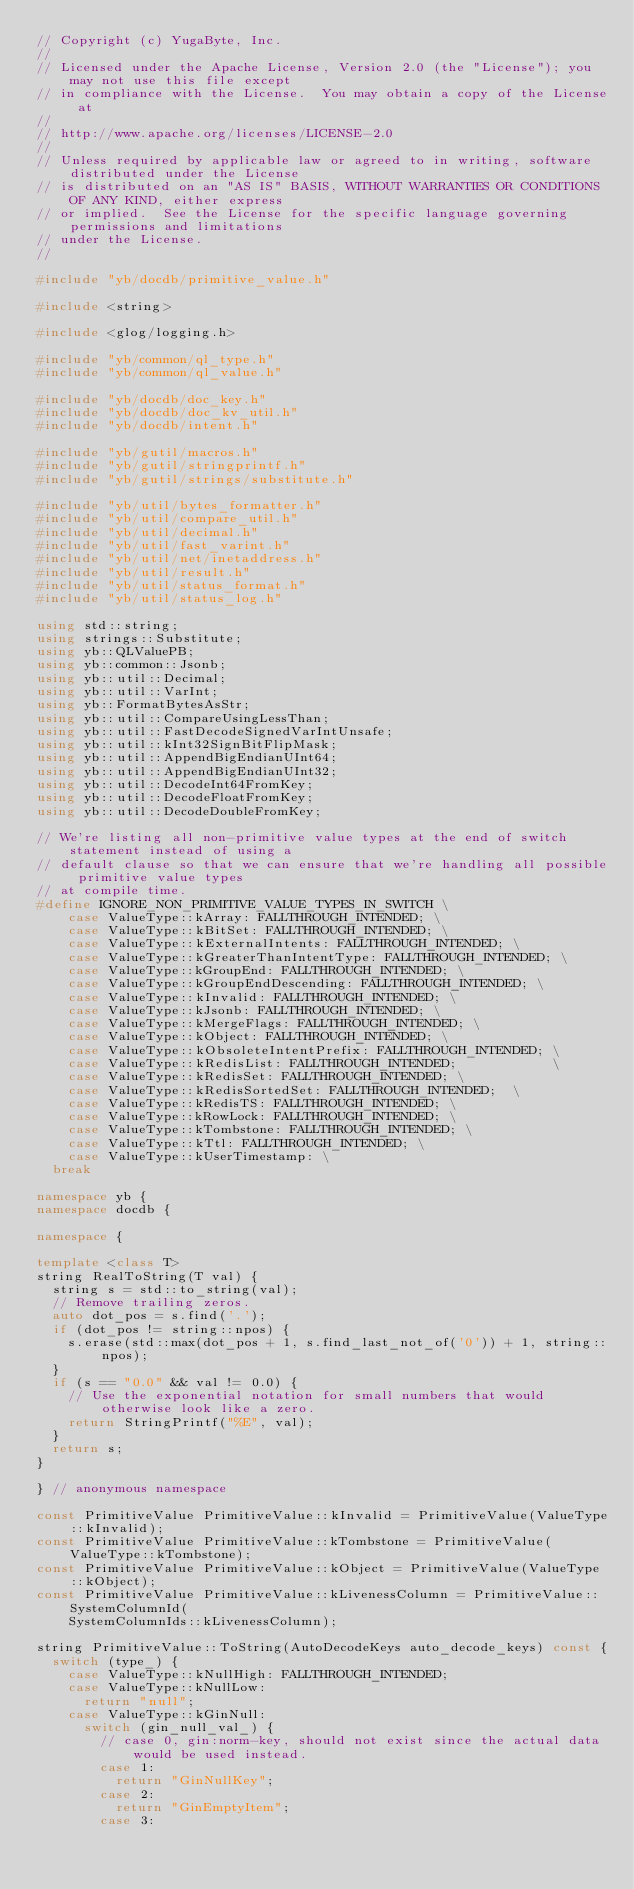Convert code to text. <code><loc_0><loc_0><loc_500><loc_500><_C++_>// Copyright (c) YugaByte, Inc.
//
// Licensed under the Apache License, Version 2.0 (the "License"); you may not use this file except
// in compliance with the License.  You may obtain a copy of the License at
//
// http://www.apache.org/licenses/LICENSE-2.0
//
// Unless required by applicable law or agreed to in writing, software distributed under the License
// is distributed on an "AS IS" BASIS, WITHOUT WARRANTIES OR CONDITIONS OF ANY KIND, either express
// or implied.  See the License for the specific language governing permissions and limitations
// under the License.
//

#include "yb/docdb/primitive_value.h"

#include <string>

#include <glog/logging.h>

#include "yb/common/ql_type.h"
#include "yb/common/ql_value.h"

#include "yb/docdb/doc_key.h"
#include "yb/docdb/doc_kv_util.h"
#include "yb/docdb/intent.h"

#include "yb/gutil/macros.h"
#include "yb/gutil/stringprintf.h"
#include "yb/gutil/strings/substitute.h"

#include "yb/util/bytes_formatter.h"
#include "yb/util/compare_util.h"
#include "yb/util/decimal.h"
#include "yb/util/fast_varint.h"
#include "yb/util/net/inetaddress.h"
#include "yb/util/result.h"
#include "yb/util/status_format.h"
#include "yb/util/status_log.h"

using std::string;
using strings::Substitute;
using yb::QLValuePB;
using yb::common::Jsonb;
using yb::util::Decimal;
using yb::util::VarInt;
using yb::FormatBytesAsStr;
using yb::util::CompareUsingLessThan;
using yb::util::FastDecodeSignedVarIntUnsafe;
using yb::util::kInt32SignBitFlipMask;
using yb::util::AppendBigEndianUInt64;
using yb::util::AppendBigEndianUInt32;
using yb::util::DecodeInt64FromKey;
using yb::util::DecodeFloatFromKey;
using yb::util::DecodeDoubleFromKey;

// We're listing all non-primitive value types at the end of switch statement instead of using a
// default clause so that we can ensure that we're handling all possible primitive value types
// at compile time.
#define IGNORE_NON_PRIMITIVE_VALUE_TYPES_IN_SWITCH \
    case ValueType::kArray: FALLTHROUGH_INTENDED; \
    case ValueType::kBitSet: FALLTHROUGH_INTENDED; \
    case ValueType::kExternalIntents: FALLTHROUGH_INTENDED; \
    case ValueType::kGreaterThanIntentType: FALLTHROUGH_INTENDED; \
    case ValueType::kGroupEnd: FALLTHROUGH_INTENDED; \
    case ValueType::kGroupEndDescending: FALLTHROUGH_INTENDED; \
    case ValueType::kInvalid: FALLTHROUGH_INTENDED; \
    case ValueType::kJsonb: FALLTHROUGH_INTENDED; \
    case ValueType::kMergeFlags: FALLTHROUGH_INTENDED; \
    case ValueType::kObject: FALLTHROUGH_INTENDED; \
    case ValueType::kObsoleteIntentPrefix: FALLTHROUGH_INTENDED; \
    case ValueType::kRedisList: FALLTHROUGH_INTENDED;            \
    case ValueType::kRedisSet: FALLTHROUGH_INTENDED; \
    case ValueType::kRedisSortedSet: FALLTHROUGH_INTENDED;  \
    case ValueType::kRedisTS: FALLTHROUGH_INTENDED; \
    case ValueType::kRowLock: FALLTHROUGH_INTENDED; \
    case ValueType::kTombstone: FALLTHROUGH_INTENDED; \
    case ValueType::kTtl: FALLTHROUGH_INTENDED; \
    case ValueType::kUserTimestamp: \
  break

namespace yb {
namespace docdb {

namespace {

template <class T>
string RealToString(T val) {
  string s = std::to_string(val);
  // Remove trailing zeros.
  auto dot_pos = s.find('.');
  if (dot_pos != string::npos) {
    s.erase(std::max(dot_pos + 1, s.find_last_not_of('0')) + 1, string::npos);
  }
  if (s == "0.0" && val != 0.0) {
    // Use the exponential notation for small numbers that would otherwise look like a zero.
    return StringPrintf("%E", val);
  }
  return s;
}

} // anonymous namespace

const PrimitiveValue PrimitiveValue::kInvalid = PrimitiveValue(ValueType::kInvalid);
const PrimitiveValue PrimitiveValue::kTombstone = PrimitiveValue(ValueType::kTombstone);
const PrimitiveValue PrimitiveValue::kObject = PrimitiveValue(ValueType::kObject);
const PrimitiveValue PrimitiveValue::kLivenessColumn = PrimitiveValue::SystemColumnId(
    SystemColumnIds::kLivenessColumn);

string PrimitiveValue::ToString(AutoDecodeKeys auto_decode_keys) const {
  switch (type_) {
    case ValueType::kNullHigh: FALLTHROUGH_INTENDED;
    case ValueType::kNullLow:
      return "null";
    case ValueType::kGinNull:
      switch (gin_null_val_) {
        // case 0, gin:norm-key, should not exist since the actual data would be used instead.
        case 1:
          return "GinNullKey";
        case 2:
          return "GinEmptyItem";
        case 3:</code> 